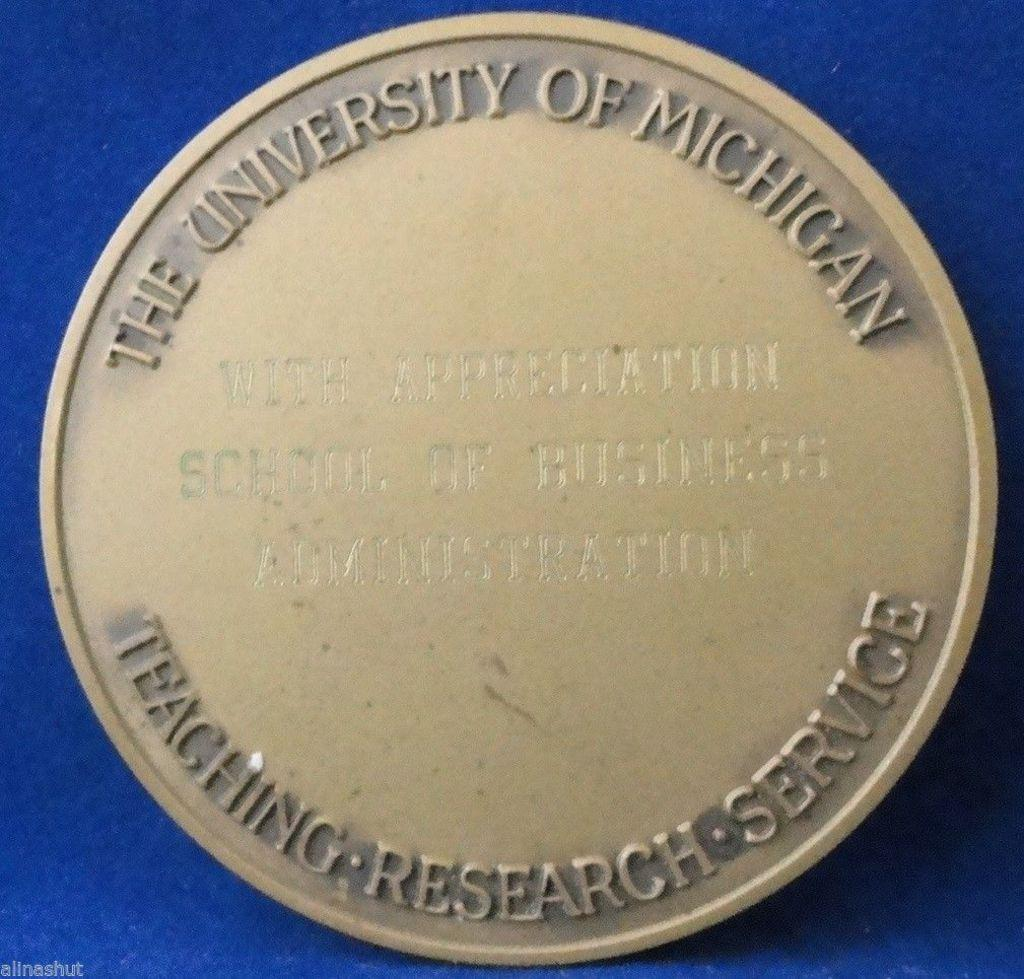<image>
Share a concise interpretation of the image provided. A coin has the words The University of Michigan across one edge. 